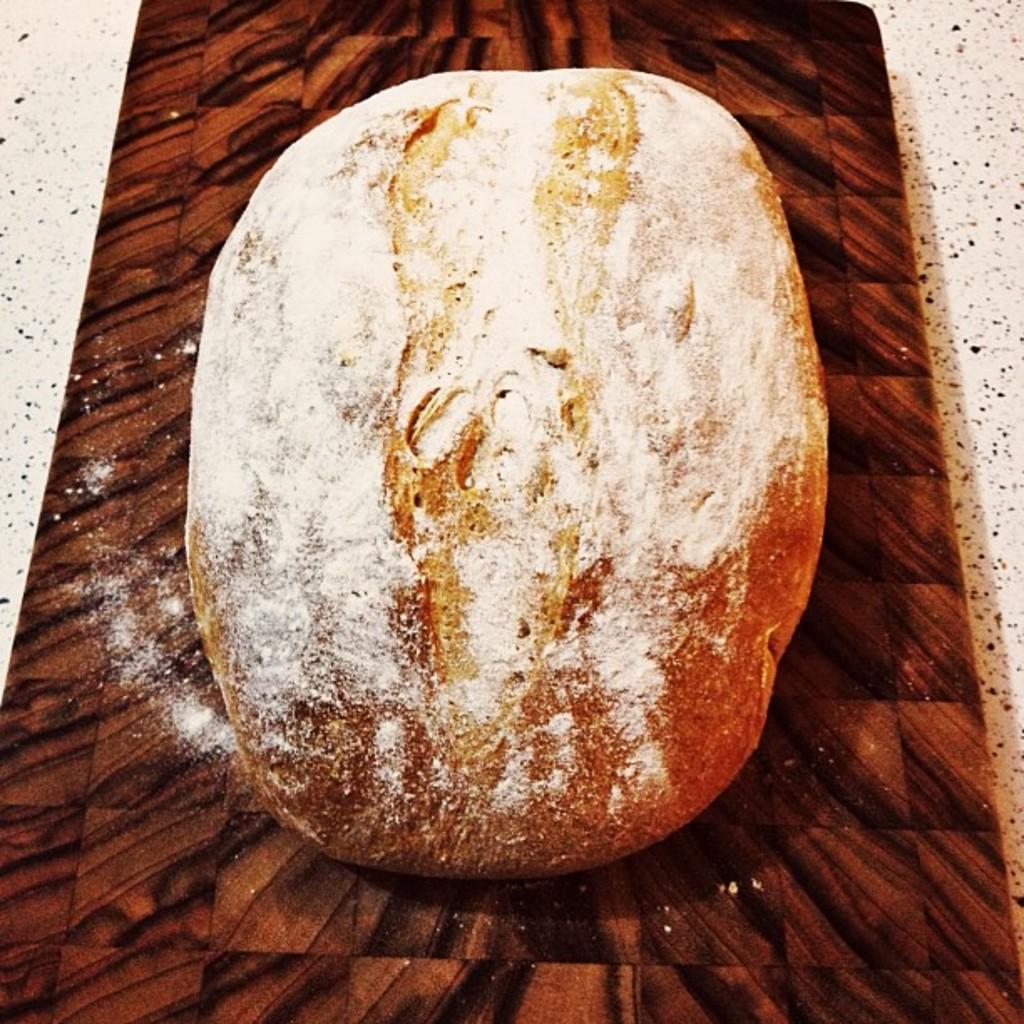Describe this image in one or two sentences. In this image I can see a food which is in brown color on some brown color object. 